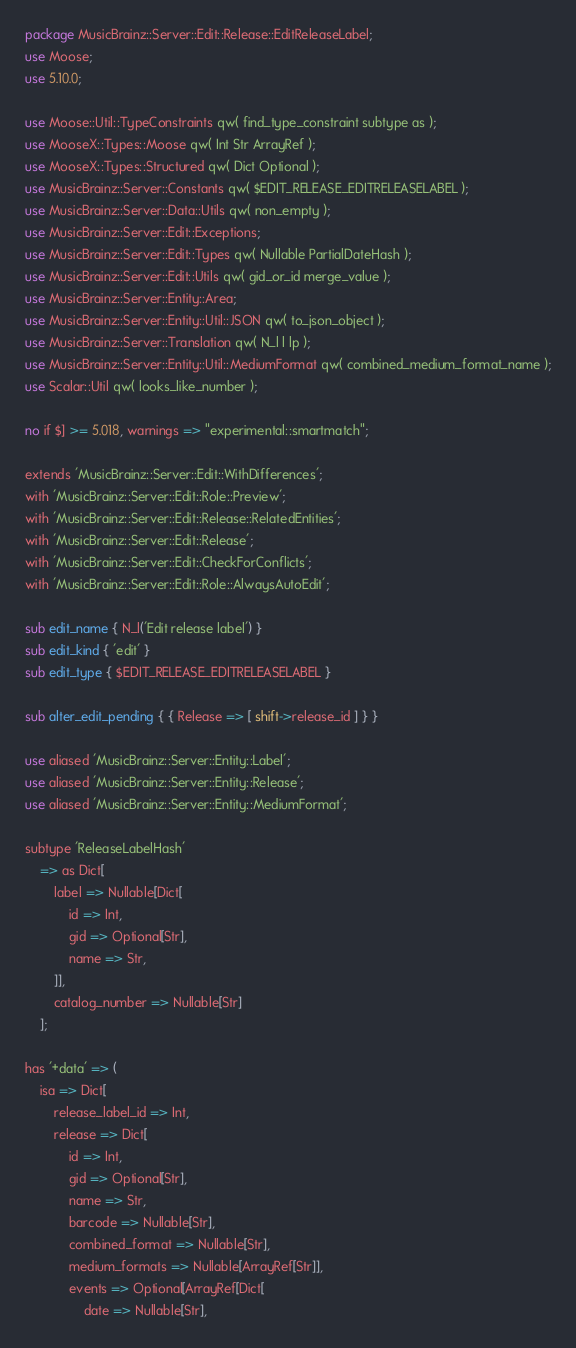<code> <loc_0><loc_0><loc_500><loc_500><_Perl_>package MusicBrainz::Server::Edit::Release::EditReleaseLabel;
use Moose;
use 5.10.0;

use Moose::Util::TypeConstraints qw( find_type_constraint subtype as );
use MooseX::Types::Moose qw( Int Str ArrayRef );
use MooseX::Types::Structured qw( Dict Optional );
use MusicBrainz::Server::Constants qw( $EDIT_RELEASE_EDITRELEASELABEL );
use MusicBrainz::Server::Data::Utils qw( non_empty );
use MusicBrainz::Server::Edit::Exceptions;
use MusicBrainz::Server::Edit::Types qw( Nullable PartialDateHash );
use MusicBrainz::Server::Edit::Utils qw( gid_or_id merge_value );
use MusicBrainz::Server::Entity::Area;
use MusicBrainz::Server::Entity::Util::JSON qw( to_json_object );
use MusicBrainz::Server::Translation qw( N_l l lp );
use MusicBrainz::Server::Entity::Util::MediumFormat qw( combined_medium_format_name );
use Scalar::Util qw( looks_like_number );

no if $] >= 5.018, warnings => "experimental::smartmatch";

extends 'MusicBrainz::Server::Edit::WithDifferences';
with 'MusicBrainz::Server::Edit::Role::Preview';
with 'MusicBrainz::Server::Edit::Release::RelatedEntities';
with 'MusicBrainz::Server::Edit::Release';
with 'MusicBrainz::Server::Edit::CheckForConflicts';
with 'MusicBrainz::Server::Edit::Role::AlwaysAutoEdit';

sub edit_name { N_l('Edit release label') }
sub edit_kind { 'edit' }
sub edit_type { $EDIT_RELEASE_EDITRELEASELABEL }

sub alter_edit_pending { { Release => [ shift->release_id ] } }

use aliased 'MusicBrainz::Server::Entity::Label';
use aliased 'MusicBrainz::Server::Entity::Release';
use aliased 'MusicBrainz::Server::Entity::MediumFormat';

subtype 'ReleaseLabelHash'
    => as Dict[
        label => Nullable[Dict[
            id => Int,
            gid => Optional[Str],
            name => Str,
        ]],
        catalog_number => Nullable[Str]
    ];

has '+data' => (
    isa => Dict[
        release_label_id => Int,
        release => Dict[
            id => Int,
            gid => Optional[Str],
            name => Str,
            barcode => Nullable[Str],
            combined_format => Nullable[Str],
            medium_formats => Nullable[ArrayRef[Str]],
            events => Optional[ArrayRef[Dict[
                date => Nullable[Str],</code> 